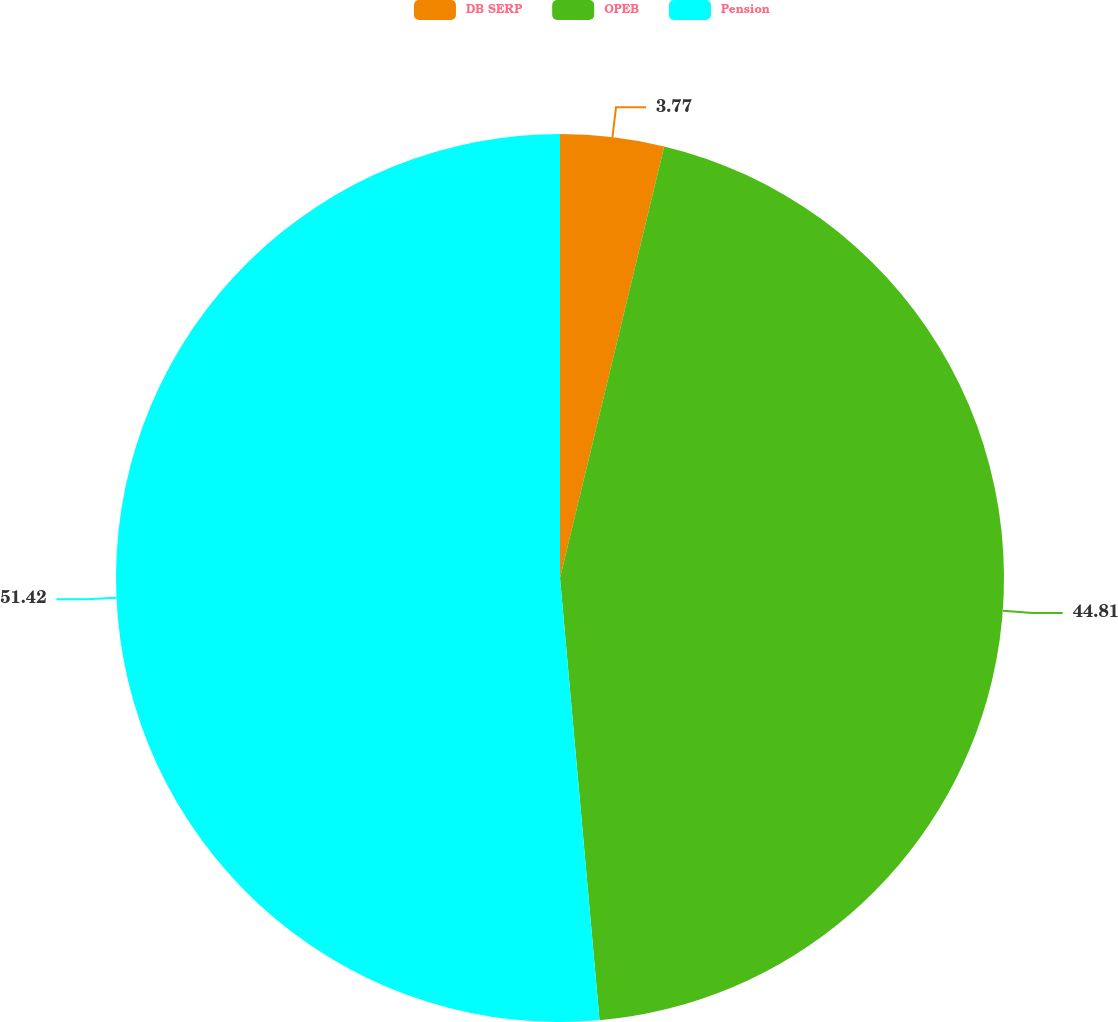<chart> <loc_0><loc_0><loc_500><loc_500><pie_chart><fcel>DB SERP<fcel>OPEB<fcel>Pension<nl><fcel>3.77%<fcel>44.81%<fcel>51.42%<nl></chart> 